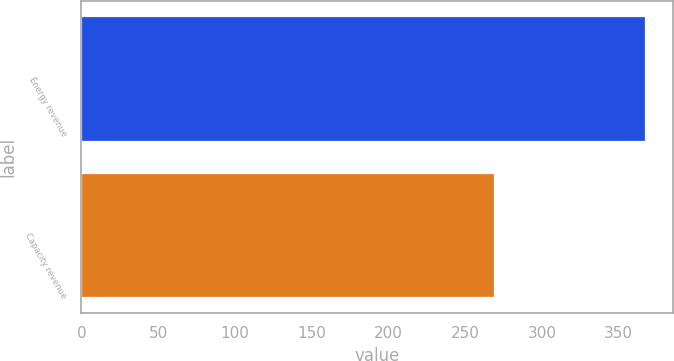Convert chart to OTSL. <chart><loc_0><loc_0><loc_500><loc_500><bar_chart><fcel>Energy revenue<fcel>Capacity revenue<nl><fcel>367<fcel>269<nl></chart> 